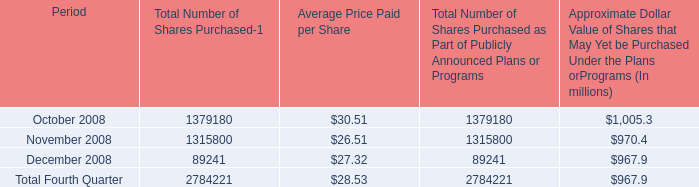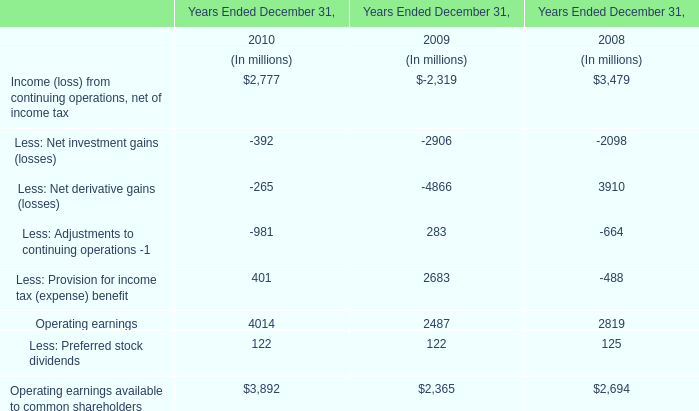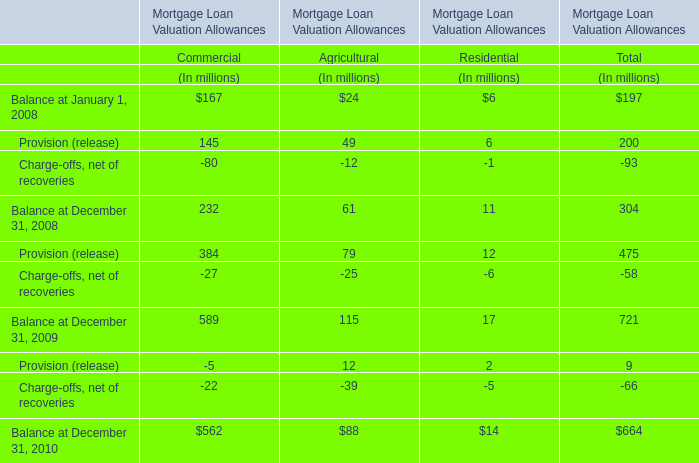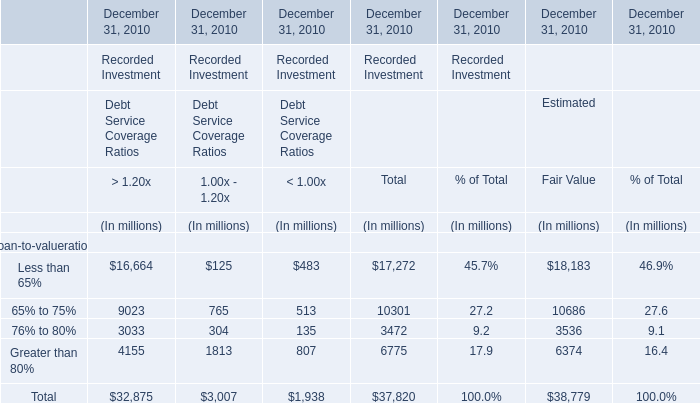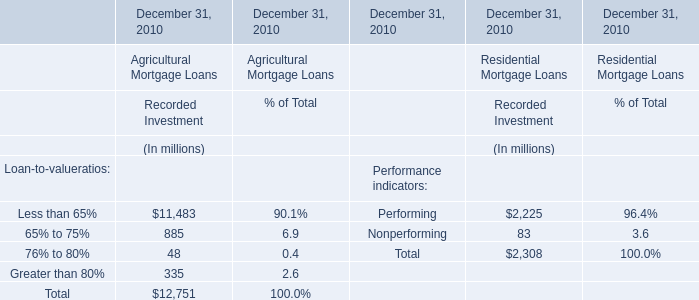What's the total value of Recorded Investment for Agricultural Mortgage Loans at December 31, 2010? (in million) 
Answer: 12751. 